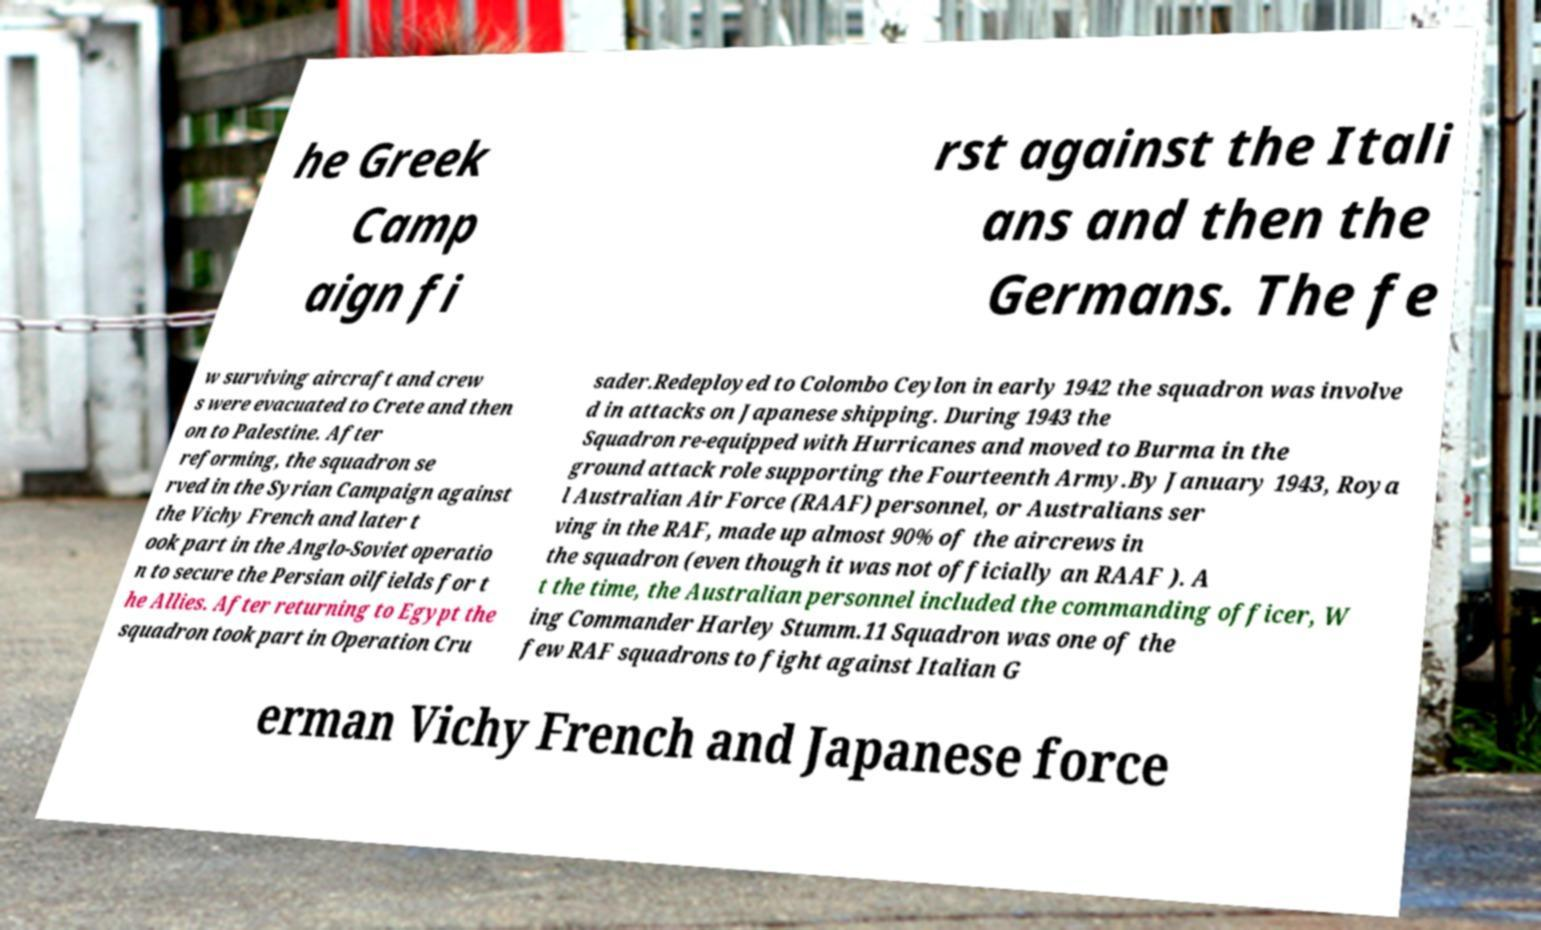I need the written content from this picture converted into text. Can you do that? he Greek Camp aign fi rst against the Itali ans and then the Germans. The fe w surviving aircraft and crew s were evacuated to Crete and then on to Palestine. After reforming, the squadron se rved in the Syrian Campaign against the Vichy French and later t ook part in the Anglo-Soviet operatio n to secure the Persian oilfields for t he Allies. After returning to Egypt the squadron took part in Operation Cru sader.Redeployed to Colombo Ceylon in early 1942 the squadron was involve d in attacks on Japanese shipping. During 1943 the Squadron re-equipped with Hurricanes and moved to Burma in the ground attack role supporting the Fourteenth Army.By January 1943, Roya l Australian Air Force (RAAF) personnel, or Australians ser ving in the RAF, made up almost 90% of the aircrews in the squadron (even though it was not officially an RAAF ). A t the time, the Australian personnel included the commanding officer, W ing Commander Harley Stumm.11 Squadron was one of the few RAF squadrons to fight against Italian G erman Vichy French and Japanese force 